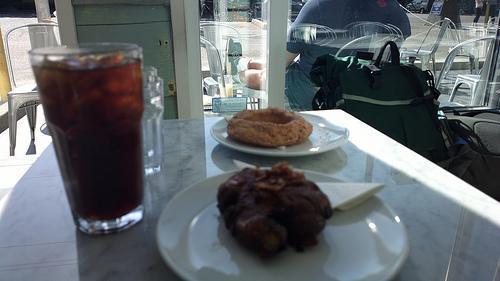How many doughnuts are there?
Give a very brief answer. 2. 